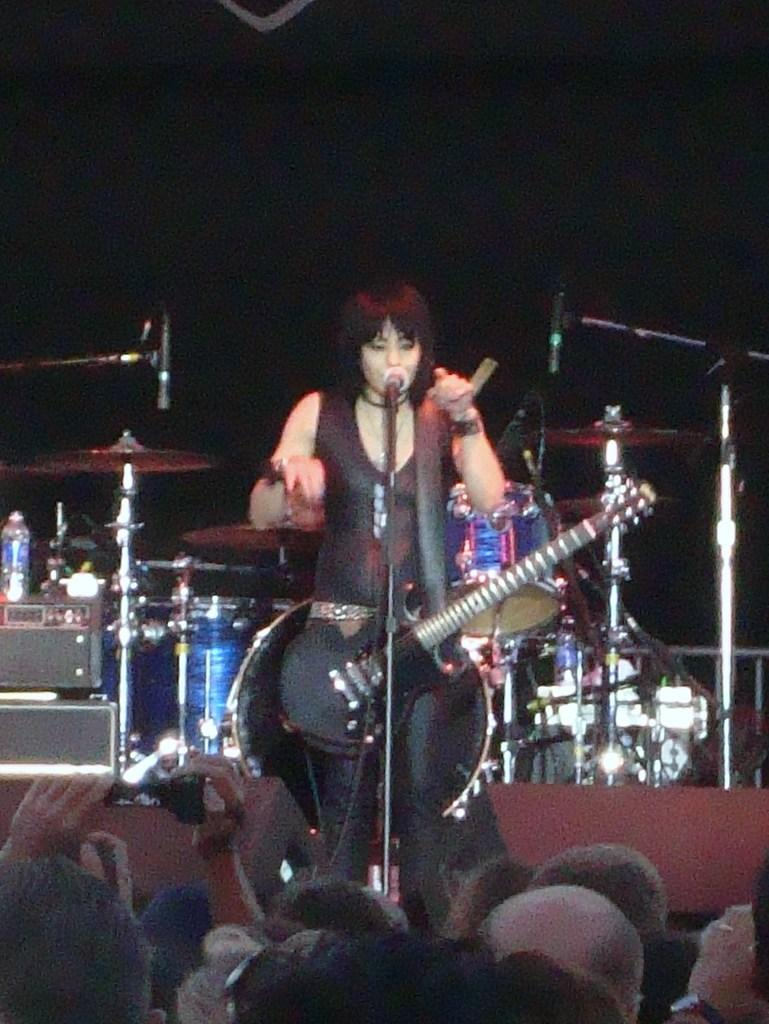What type of event is taking place in the image? The image is from a concert. What is the woman in the image doing? The woman is singing and playing guitar. What can be seen in the background of the image? There is a band setup in the background. How many people are visible at the bottom of the image? There are many people at the bottom of the image. What is the woman's belief about the importance of teamwork in the image? There is no information about the woman's beliefs or opinions in the image. 